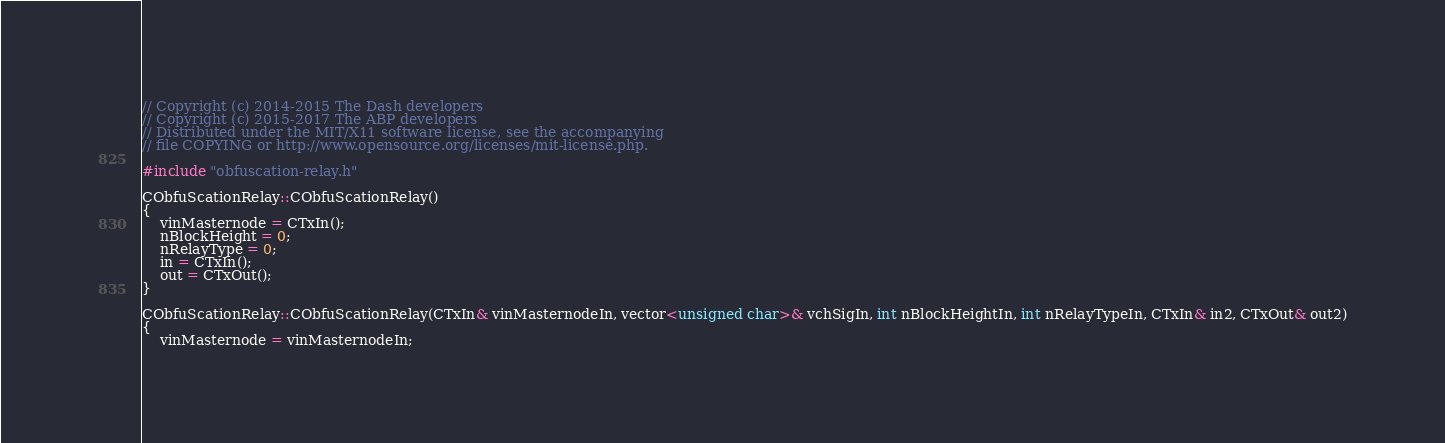<code> <loc_0><loc_0><loc_500><loc_500><_C++_>// Copyright (c) 2014-2015 The Dash developers
// Copyright (c) 2015-2017 The ABP developers
// Distributed under the MIT/X11 software license, see the accompanying
// file COPYING or http://www.opensource.org/licenses/mit-license.php.

#include "obfuscation-relay.h"

CObfuScationRelay::CObfuScationRelay()
{
    vinMasternode = CTxIn();
    nBlockHeight = 0;
    nRelayType = 0;
    in = CTxIn();
    out = CTxOut();
}

CObfuScationRelay::CObfuScationRelay(CTxIn& vinMasternodeIn, vector<unsigned char>& vchSigIn, int nBlockHeightIn, int nRelayTypeIn, CTxIn& in2, CTxOut& out2)
{
    vinMasternode = vinMasternodeIn;</code> 